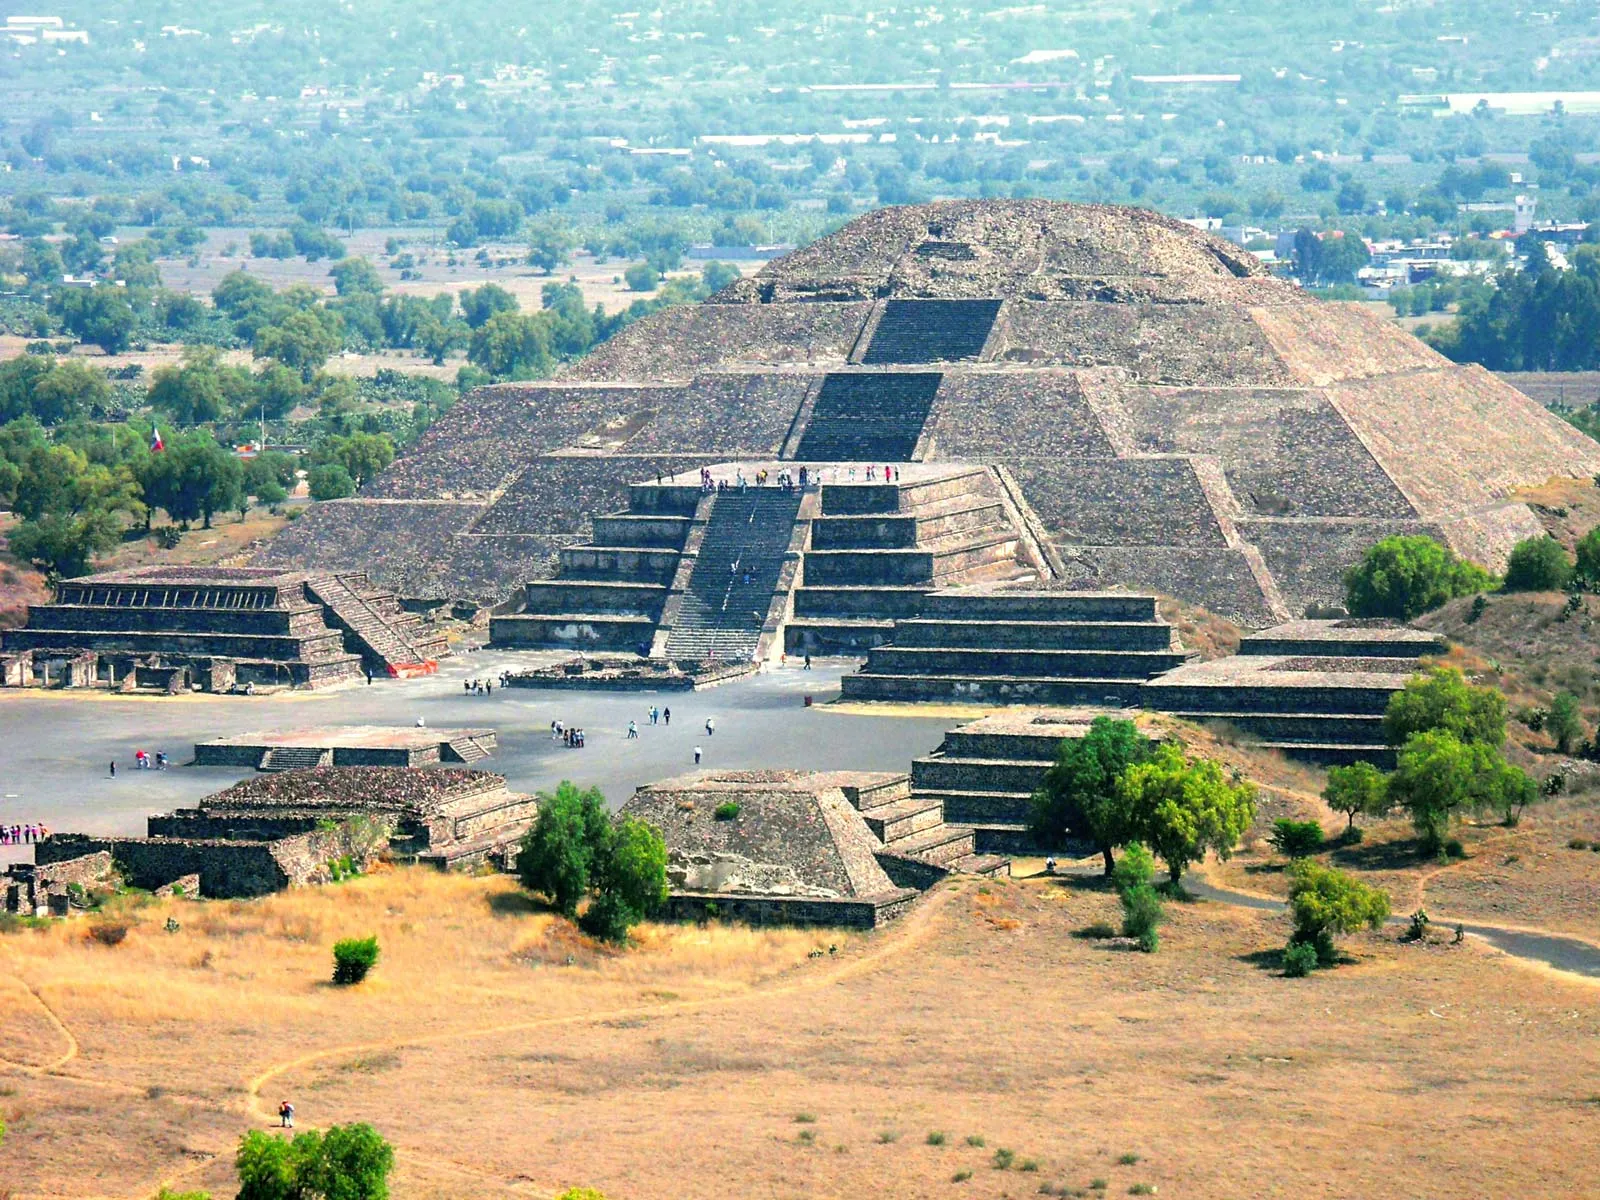How might the Pyramid of the Sun have appeared during its peak use in ancient times? During its peak use in ancient times, the Pyramid of the Sun would have appeared even more magnificent than it does today. The pyramid might have been adorned with vibrant murals and carvings, depicting deities, celestial events, and important cultural narratives. The area around the pyramid would have been bustling with activity; priests performing elaborate ceremonies, traders selling a variety of goods, and citizens participating in communal events. The smaller structures surrounding the pyramid would have been well-maintained, serving various functions such as administrative, residential, or ritualistic purposes. The landscape would have been teeming with life, with cultivated fields and gardens showcasing the agricultural prowess of the Teotihuacan people. The pyramid itself would have stood as a proud emblem of the civilization's spiritual, social, and architectural achievements. 